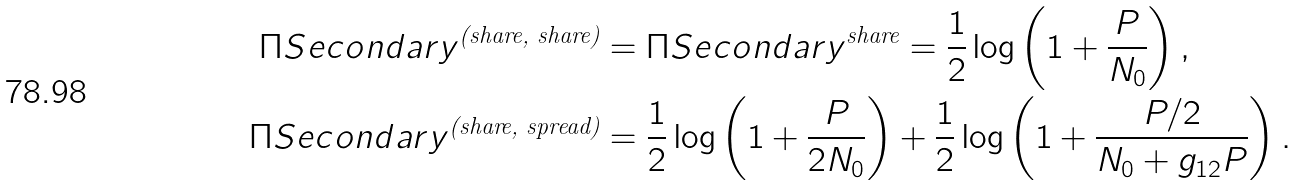Convert formula to latex. <formula><loc_0><loc_0><loc_500><loc_500>\Pi S e c o n d a r y ^ { \text {(share, share)} } & = \Pi S e c o n d a r y ^ { \text {share} } = \frac { 1 } { 2 } \log \left ( 1 + \frac { P } { N _ { 0 } } \right ) , \\ \Pi S e c o n d a r y ^ { \text {(share, spread)} } & = \frac { 1 } { 2 } \log \left ( 1 + \frac { P } { 2 N _ { 0 } } \right ) + \frac { 1 } { 2 } \log \left ( 1 + \frac { P / 2 } { N _ { 0 } + g _ { 1 2 } P } \right ) .</formula> 